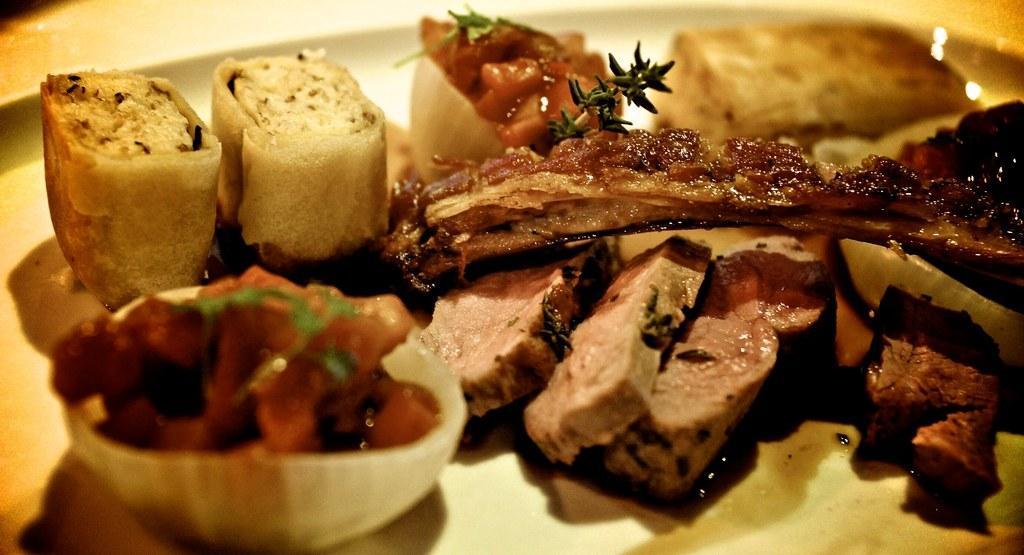In one or two sentences, can you explain what this image depicts? In this image I see a plate on which there is food which is of cream, brown, red and green in color and I see a bowl which is of white in color and there is food which is of red and green in color. 